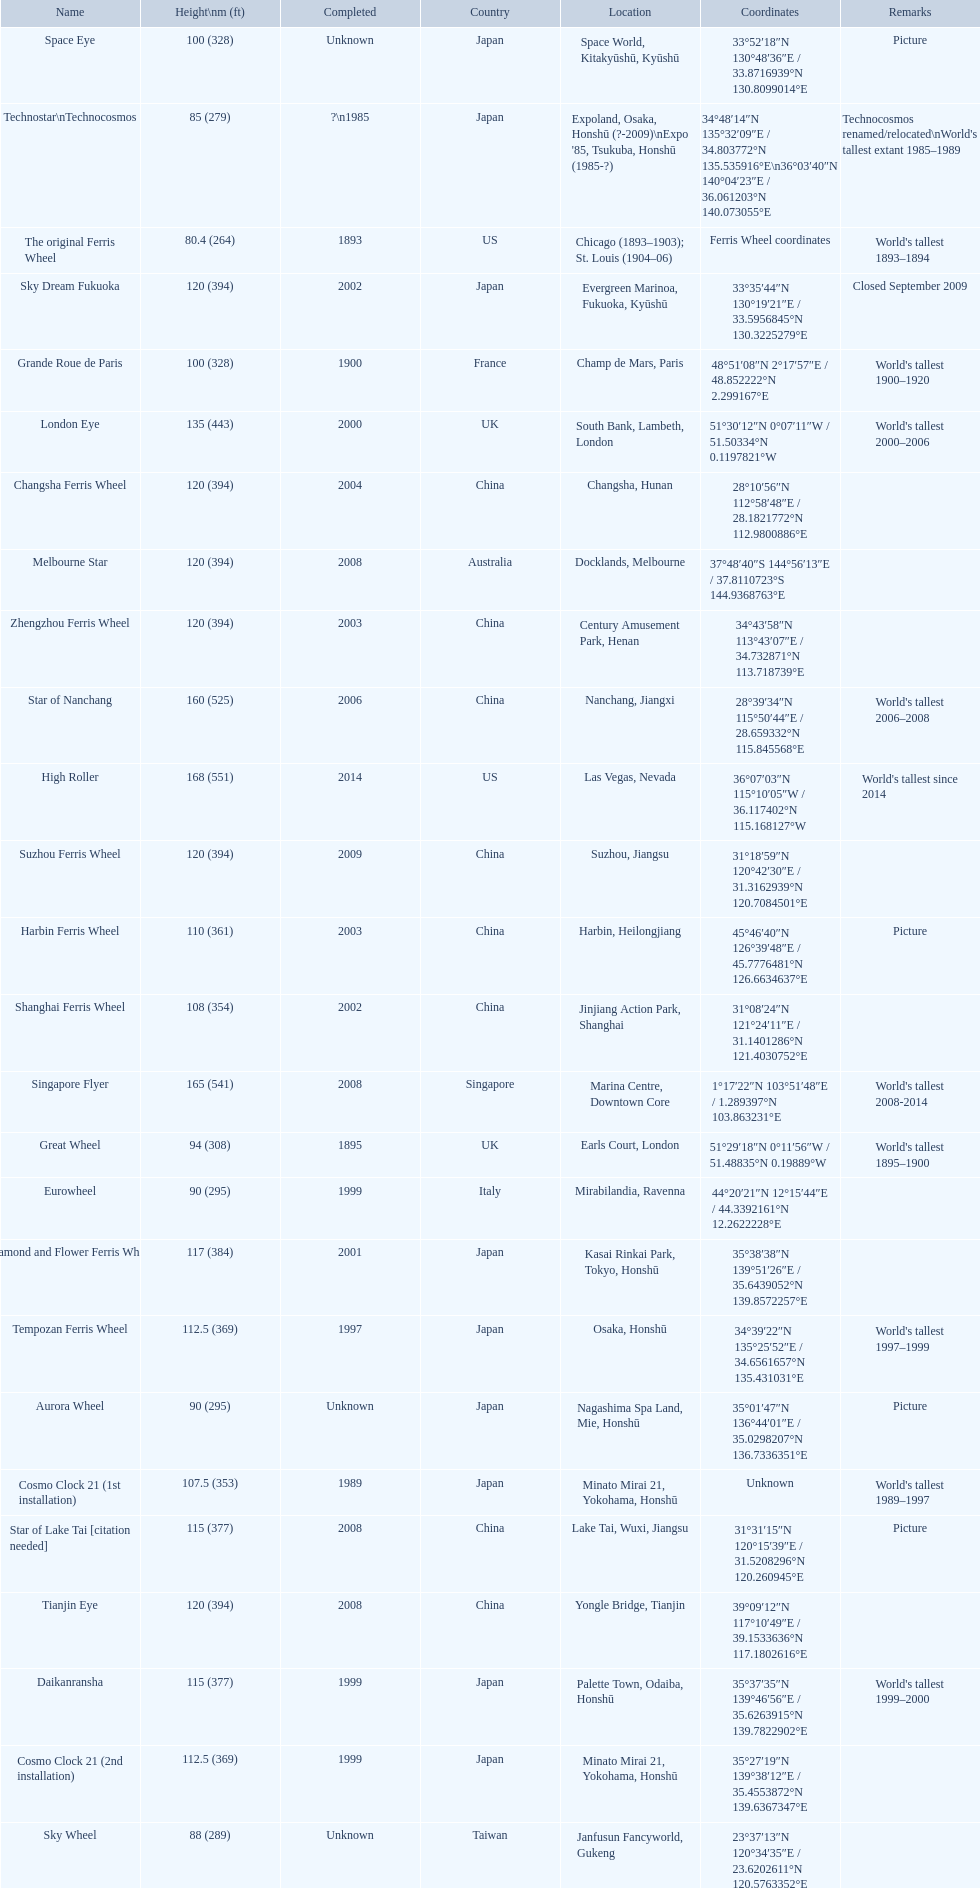What are all of the ferris wheel names? High Roller, Singapore Flyer, Star of Nanchang, London Eye, Suzhou Ferris Wheel, Melbourne Star, Tianjin Eye, Changsha Ferris Wheel, Zhengzhou Ferris Wheel, Sky Dream Fukuoka, Diamond and Flower Ferris Wheel, Star of Lake Tai [citation needed], Daikanransha, Cosmo Clock 21 (2nd installation), Tempozan Ferris Wheel, Harbin Ferris Wheel, Shanghai Ferris Wheel, Cosmo Clock 21 (1st installation), Space Eye, Grande Roue de Paris, Great Wheel, Aurora Wheel, Eurowheel, Sky Wheel, Technostar\nTechnocosmos, The original Ferris Wheel. What was the height of each one? 168 (551), 165 (541), 160 (525), 135 (443), 120 (394), 120 (394), 120 (394), 120 (394), 120 (394), 120 (394), 117 (384), 115 (377), 115 (377), 112.5 (369), 112.5 (369), 110 (361), 108 (354), 107.5 (353), 100 (328), 100 (328), 94 (308), 90 (295), 90 (295), 88 (289), 85 (279), 80.4 (264). And when were they completed? 2014, 2008, 2006, 2000, 2009, 2008, 2008, 2004, 2003, 2002, 2001, 2008, 1999, 1999, 1997, 2003, 2002, 1989, Unknown, 1900, 1895, Unknown, 1999, Unknown, ?\n1985, 1893. Which were completed in 2008? Singapore Flyer, Melbourne Star, Tianjin Eye, Star of Lake Tai [citation needed]. And of those ferris wheels, which had a height of 165 meters? Singapore Flyer. 